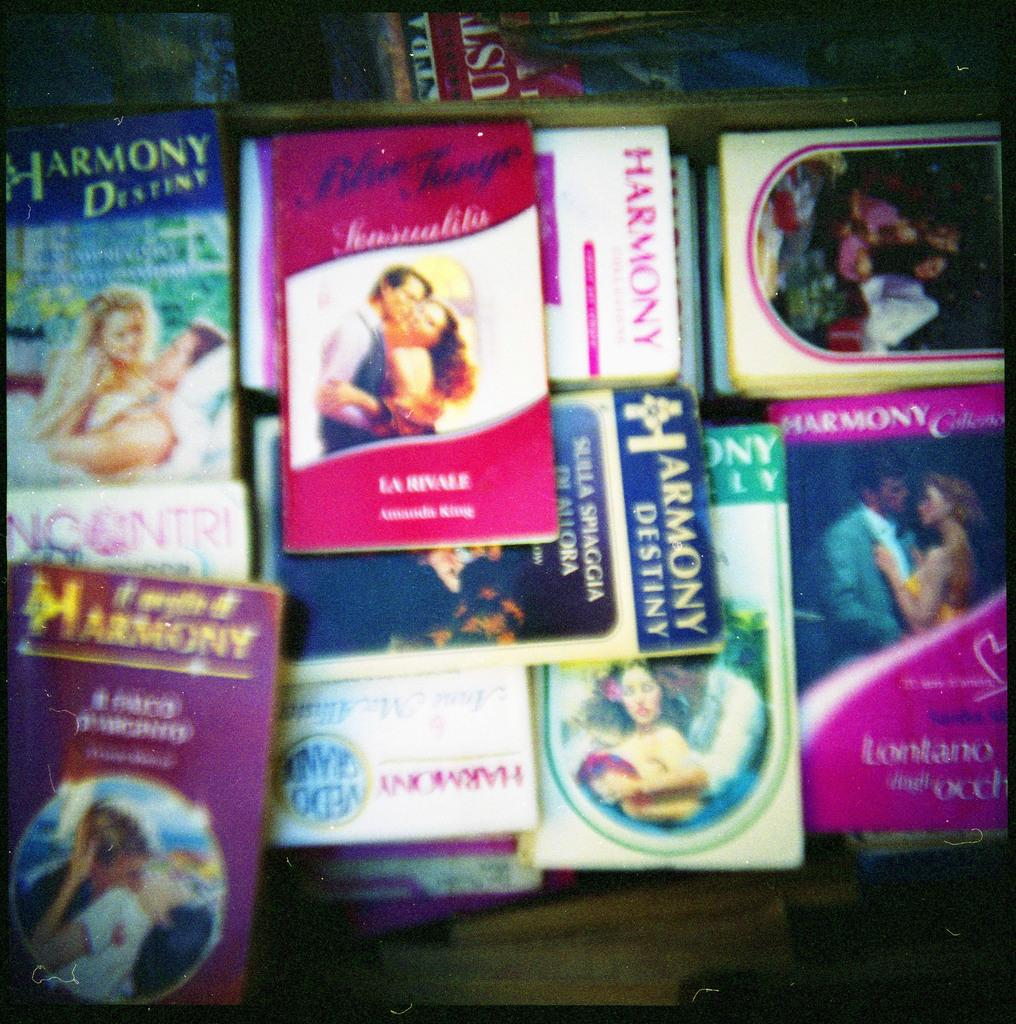Provide a one-sentence caption for the provided image. Many soft back romantic books in a pile, including some from the Harmony Destiny series. 